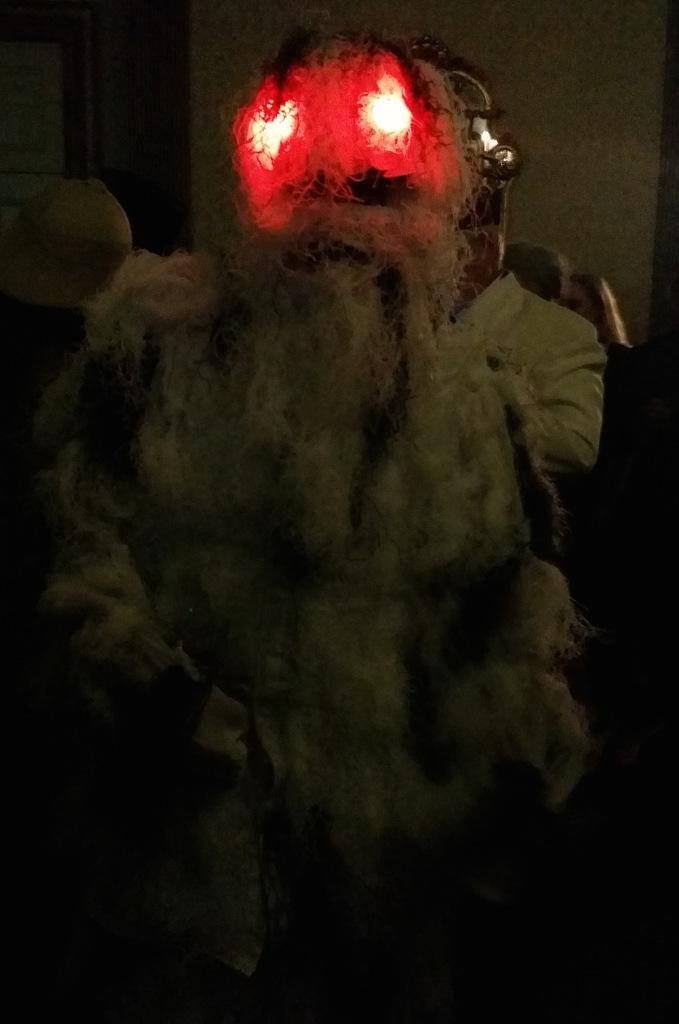How many people are in the image? There is a group of people in the image. Can you describe the costume of one of the people in the image? One person is wearing a devil costume. What type of breakfast is being served in the image? There is no breakfast visible in the image. 